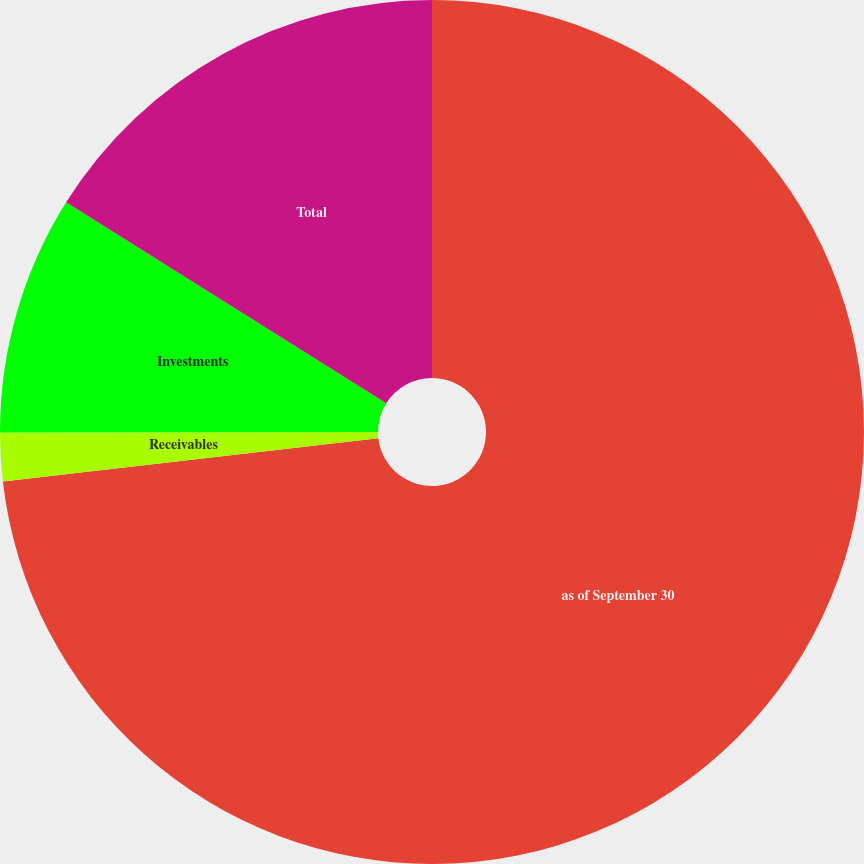Convert chart. <chart><loc_0><loc_0><loc_500><loc_500><pie_chart><fcel>as of September 30<fcel>Receivables<fcel>Investments<fcel>Total<nl><fcel>73.17%<fcel>1.81%<fcel>8.94%<fcel>16.08%<nl></chart> 